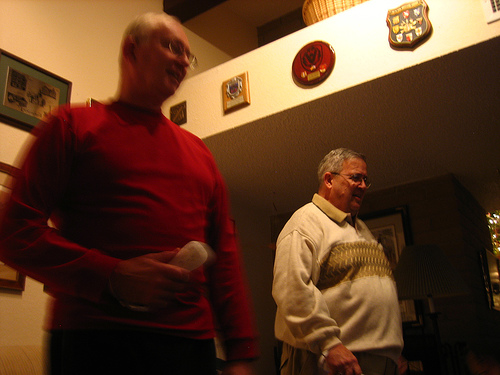Who is wearing a sweater? The man standing to the right in the image is the one wearing a cream-colored sweater with a pattern. 